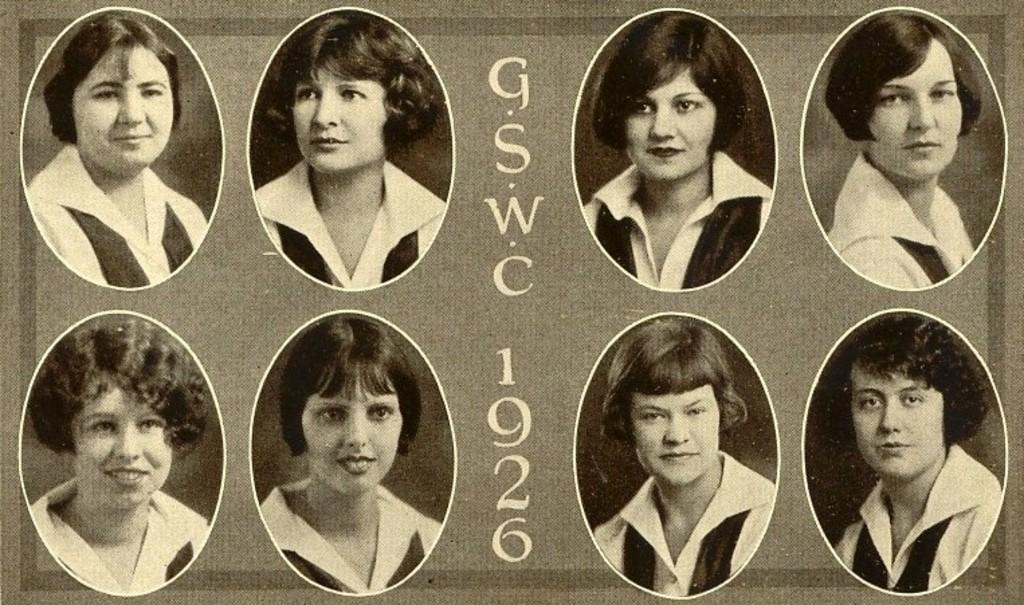What is the main subject of the image? The main subject of the image is a poster. What type of content is featured on the poster? The poster contains photographs of people. Is there any text present on the poster? Yes, there is text present on the poster. What type of toys can be seen in the image? There are no toys present in the image; it features a poster with photographs of people and text. 